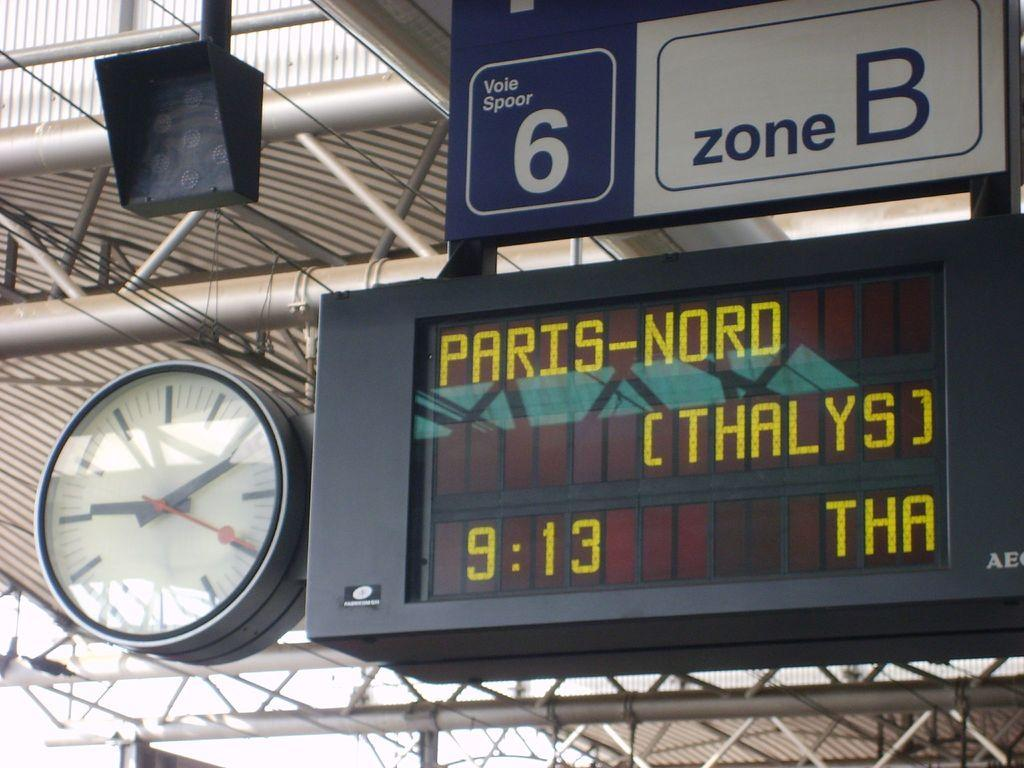<image>
Offer a succinct explanation of the picture presented. The section 6 zone B arrival board at a train station is displaying the information for Paris-Nord. 